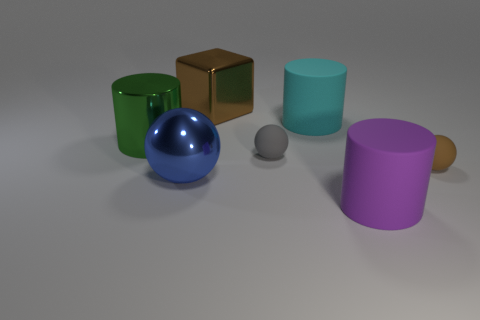Is the number of large balls that are right of the big cyan matte thing greater than the number of large yellow cylinders?
Provide a succinct answer. No. Are there an equal number of big brown things in front of the purple cylinder and cylinders on the left side of the metallic cylinder?
Keep it short and to the point. Yes. There is a cylinder that is behind the blue thing and on the right side of the large blue thing; what is its color?
Your response must be concise. Cyan. Are there any other things that have the same size as the green shiny cylinder?
Your answer should be compact. Yes. Is the number of tiny matte things that are in front of the big shiny ball greater than the number of large cyan cylinders to the left of the brown metal thing?
Make the answer very short. No. There is a matte sphere that is right of the cyan rubber cylinder; is its size the same as the purple thing?
Offer a very short reply. No. There is a large metal object that is behind the green object that is in front of the large brown cube; what number of large purple matte things are in front of it?
Your response must be concise. 1. What size is the thing that is in front of the large green metal object and left of the large brown metallic cube?
Give a very brief answer. Large. What number of other things are there of the same shape as the big cyan matte thing?
Ensure brevity in your answer.  2. There is a big green cylinder; what number of big cyan objects are on the left side of it?
Provide a short and direct response. 0. 